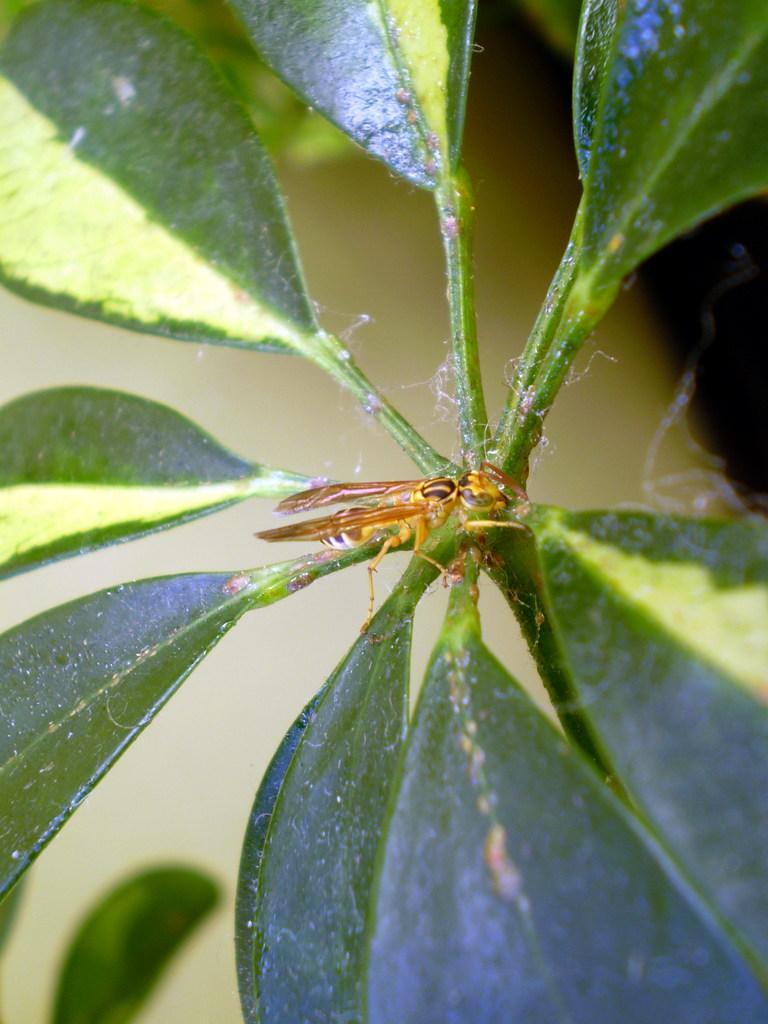How would you summarize this image in a sentence or two? In this picture we can see a few green leaves on a plant. 